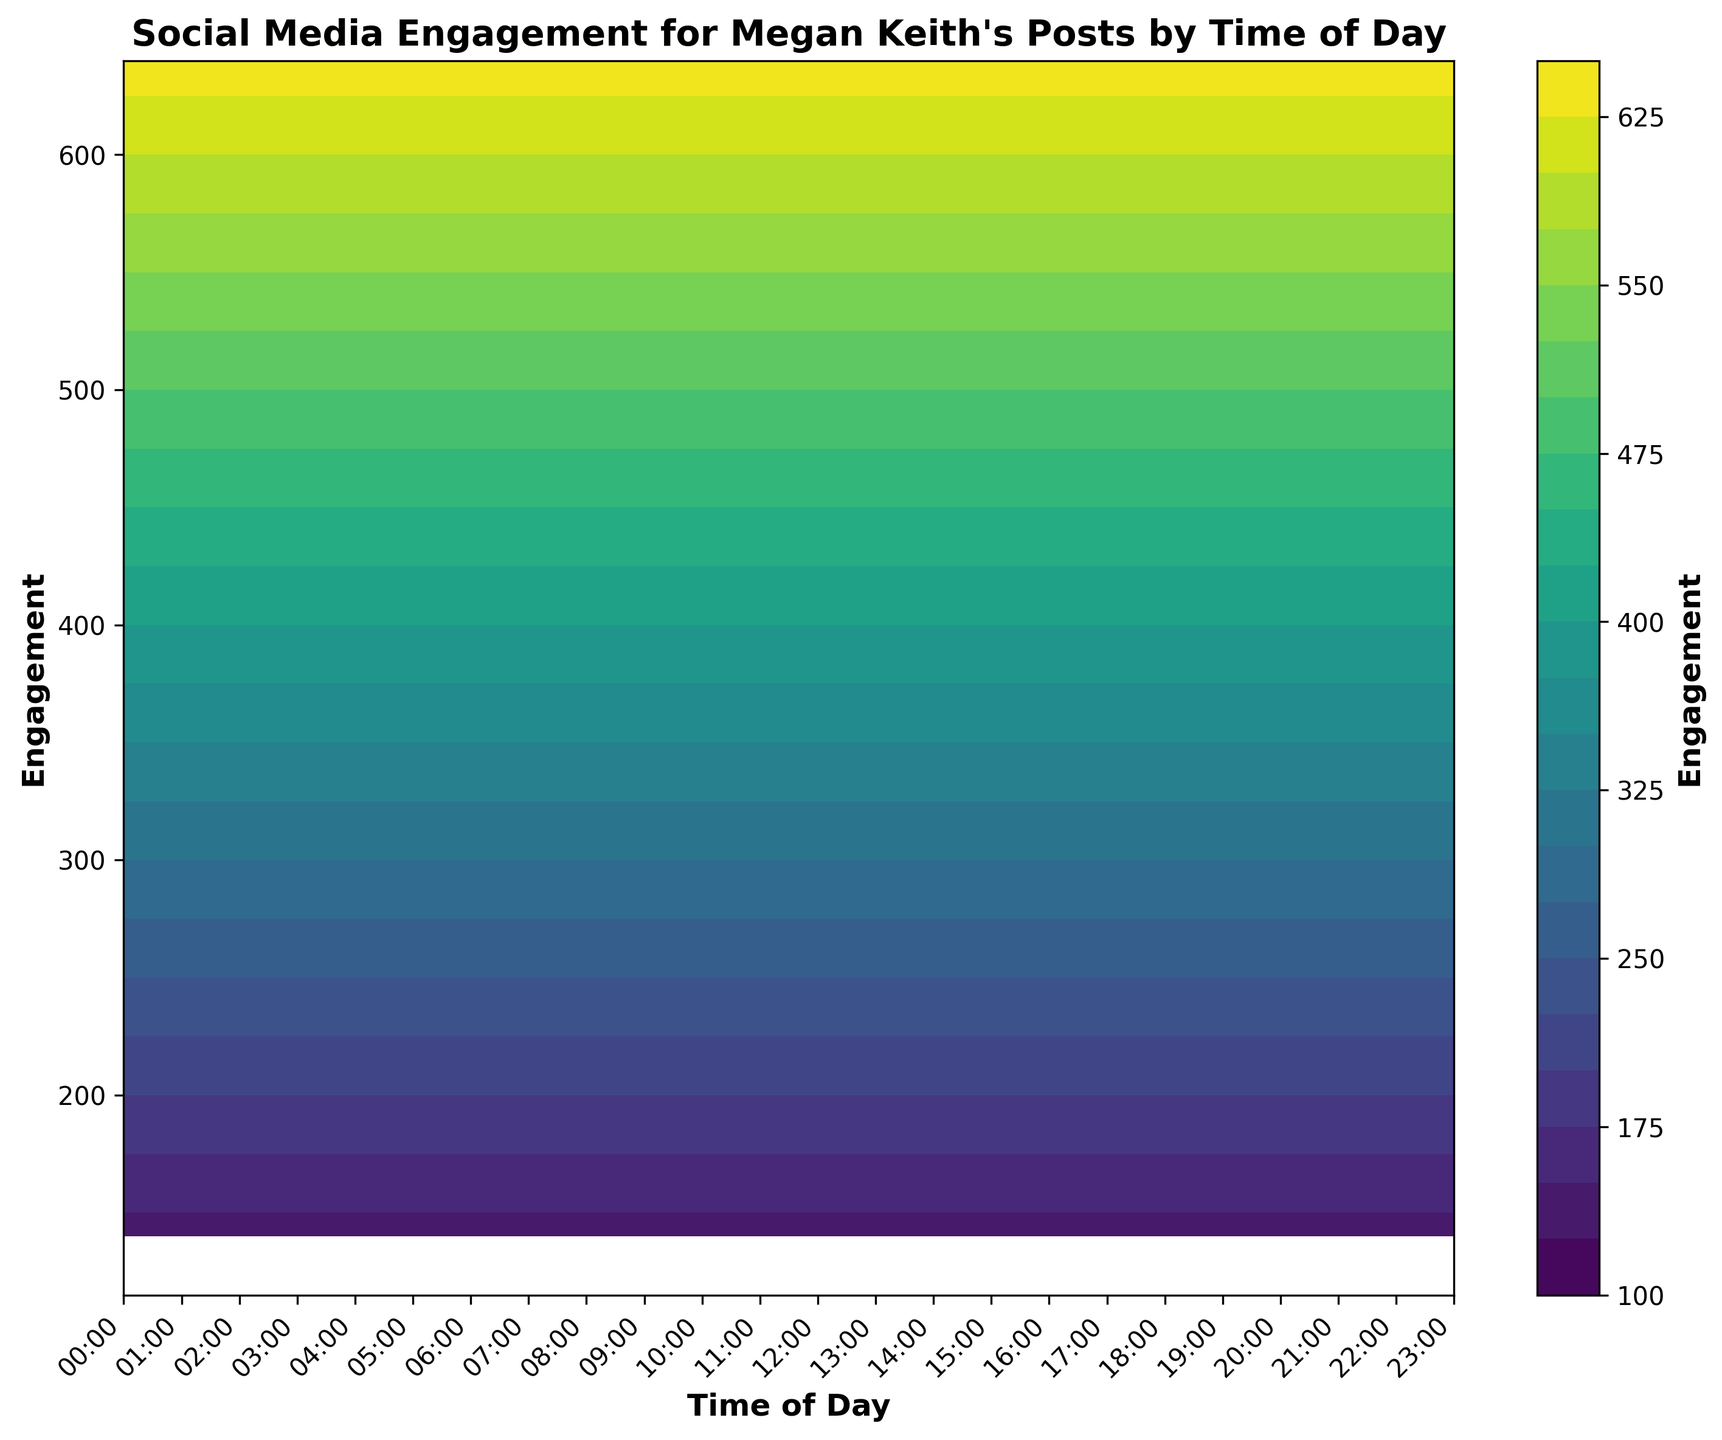Which time of day has the highest engagement? Looking at the contour plot, the darkest area on the color map indicates the highest engagement. The engagement peaks around 23:00.
Answer: 23:00 What is the engagement around 06:00? By locating 06:00 on the x-axis and observing the contour color, the engagement is around 200.
Answer: 200 When does the engagement start to significantly increase after the lowest point early in the morning? Observing the gradual change in color, engagement starts to significantly increase after the lowest engagement point at 04:00, starting around 05:00.
Answer: 05:00 Compare the engagement between 12:00 and 18:00. By comparing the contour shades for both times, 18:00 has a darker shade indicating a higher engagement compared to 12:00.
Answer: 18:00 What is the approximate engagement at noon (12:00)? By locating 12:00 on the x-axis and referring to the color contour, the engagement is approximately 500.
Answer: 500 Which two time periods have an engagement difference of approximately 400? Locating different time periods and checking the engagement values, 09:00 with 450 engagement and 04:00 with 115 engagement give a difference of 335. So more appropriate periods, such as 20:00 (610) and 02:00 (130), yield a difference of approx 480 which is closer.
Answer: 20:00 and 02:00 How does the engagement at 11:00 compare to the engagement at 23:00? Looking at the contour plot, engage ment at 23:00 is higher than at 11:00. The engagement at 23:00 is around 640, while at 11:00 is around 480.
Answer: 23:00 > 11:00 What is the engagement trend seen in the plot from early morning to late night? Observing from left to right on the x-axis, engagement starts low around early morning (00:00 - 04:00), increases steadily throughout the day, peaks around late evening (22:00 - 23:00).
Answer: Low to High 